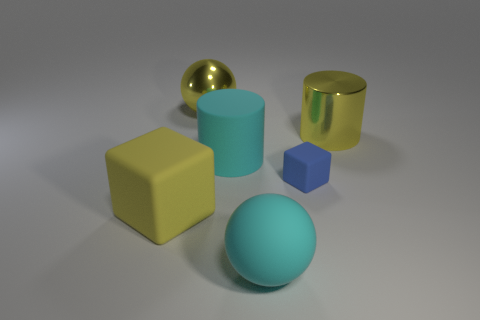Subtract 2 spheres. How many spheres are left? 0 Add 4 blue shiny cubes. How many objects exist? 10 Subtract all spheres. How many objects are left? 4 Add 2 blue objects. How many blue objects exist? 3 Subtract 1 cyan spheres. How many objects are left? 5 Subtract all yellow cubes. Subtract all gray spheres. How many cubes are left? 1 Subtract all cyan spheres. How many red cylinders are left? 0 Subtract all large cyan rubber things. Subtract all big cyan things. How many objects are left? 2 Add 5 big spheres. How many big spheres are left? 7 